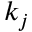Convert formula to latex. <formula><loc_0><loc_0><loc_500><loc_500>k _ { j }</formula> 